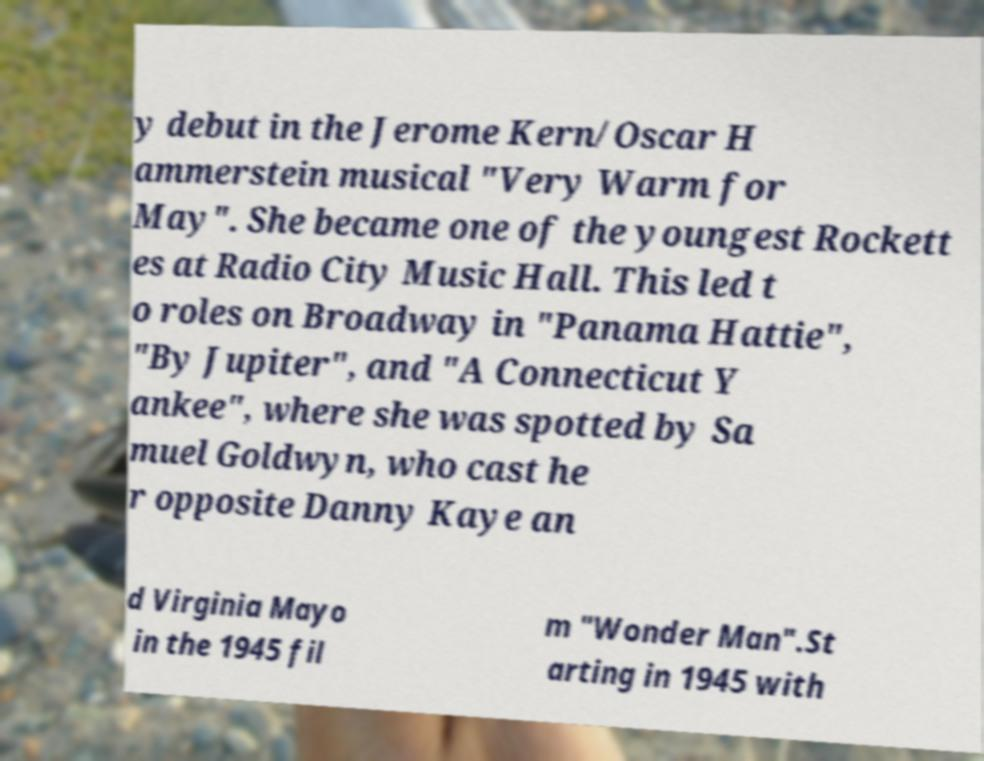Please identify and transcribe the text found in this image. y debut in the Jerome Kern/Oscar H ammerstein musical "Very Warm for May". She became one of the youngest Rockett es at Radio City Music Hall. This led t o roles on Broadway in "Panama Hattie", "By Jupiter", and "A Connecticut Y ankee", where she was spotted by Sa muel Goldwyn, who cast he r opposite Danny Kaye an d Virginia Mayo in the 1945 fil m "Wonder Man".St arting in 1945 with 